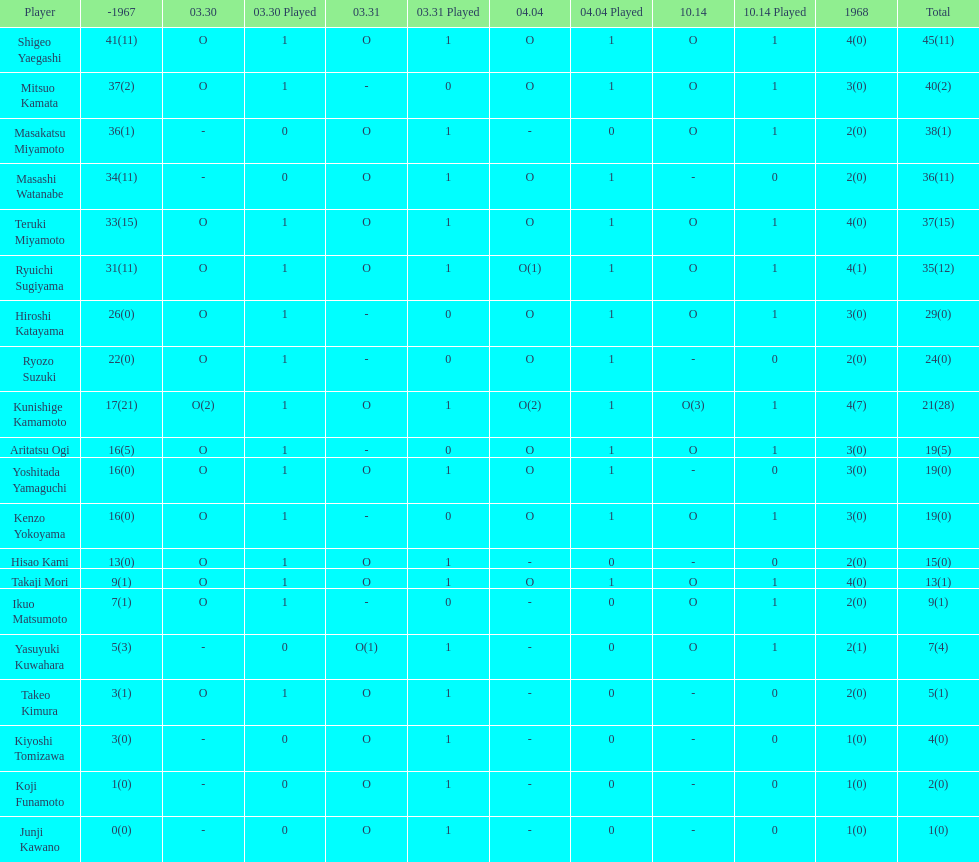How many more total appearances did shigeo yaegashi have than mitsuo kamata? 5. 